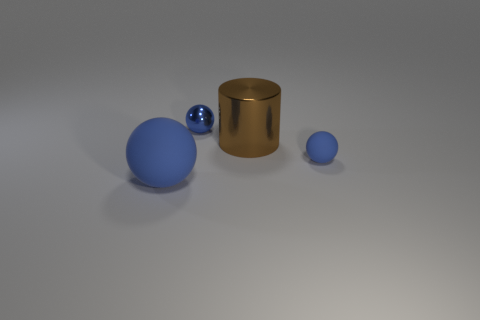There is a rubber ball that is the same size as the blue metallic thing; what is its color?
Ensure brevity in your answer.  Blue. There is a tiny blue object that is in front of the large cylinder; what number of brown metallic cylinders are behind it?
Your answer should be compact. 1. How many objects are either metal objects that are behind the big metal object or rubber balls?
Make the answer very short. 3. What number of brown things have the same material as the cylinder?
Give a very brief answer. 0. What shape is the large object that is the same color as the small rubber ball?
Make the answer very short. Sphere. Is the number of things to the right of the large blue ball the same as the number of large brown shiny cylinders?
Your answer should be very brief. No. How big is the rubber ball right of the big matte ball?
Your response must be concise. Small. What number of big objects are blue balls or green spheres?
Make the answer very short. 1. What is the color of the other big object that is the same shape as the blue metallic object?
Provide a short and direct response. Blue. Is the size of the metal ball the same as the metallic cylinder?
Your answer should be compact. No. 